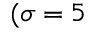<formula> <loc_0><loc_0><loc_500><loc_500>( \sigma = 5</formula> 